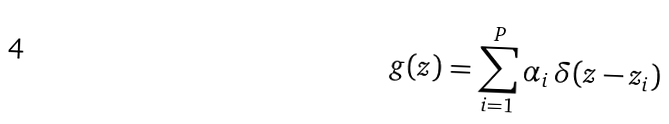Convert formula to latex. <formula><loc_0><loc_0><loc_500><loc_500>g ( z ) = \sum _ { i = 1 } ^ { P } \alpha _ { i } \, \delta ( z - z _ { i } )</formula> 